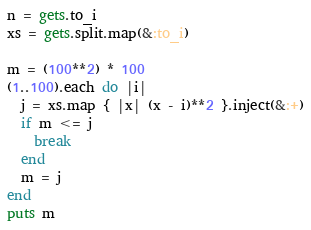<code> <loc_0><loc_0><loc_500><loc_500><_Ruby_>n = gets.to_i
xs = gets.split.map(&:to_i)

m = (100**2) * 100
(1..100).each do |i|
  j = xs.map { |x| (x - i)**2 }.inject(&:+)
  if m <= j
    break
  end
  m = j
end
puts m
</code> 